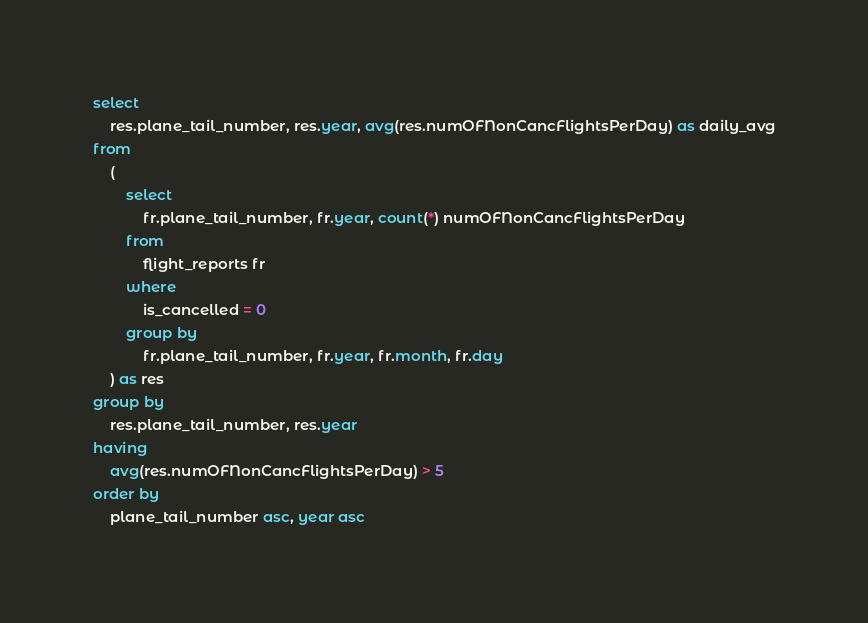<code> <loc_0><loc_0><loc_500><loc_500><_SQL_>select
	res.plane_tail_number, res.year, avg(res.numOFNonCancFlightsPerDay) as daily_avg
from
	(
		select
			fr.plane_tail_number, fr.year, count(*) numOFNonCancFlightsPerDay
		from
			flight_reports fr 
		where
			is_cancelled = 0
		group by 
			fr.plane_tail_number, fr.year, fr.month, fr.day
	) as res
group by
	res.plane_tail_number, res.year
having
	avg(res.numOFNonCancFlightsPerDay) > 5
order by
	plane_tail_number asc, year asc</code> 